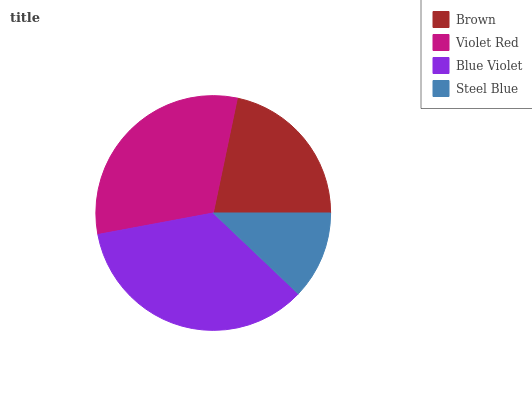Is Steel Blue the minimum?
Answer yes or no. Yes. Is Blue Violet the maximum?
Answer yes or no. Yes. Is Violet Red the minimum?
Answer yes or no. No. Is Violet Red the maximum?
Answer yes or no. No. Is Violet Red greater than Brown?
Answer yes or no. Yes. Is Brown less than Violet Red?
Answer yes or no. Yes. Is Brown greater than Violet Red?
Answer yes or no. No. Is Violet Red less than Brown?
Answer yes or no. No. Is Violet Red the high median?
Answer yes or no. Yes. Is Brown the low median?
Answer yes or no. Yes. Is Steel Blue the high median?
Answer yes or no. No. Is Steel Blue the low median?
Answer yes or no. No. 